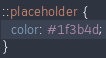<code> <loc_0><loc_0><loc_500><loc_500><_CSS_>::placeholder {
  color: #1f3b4d;
}
</code> 